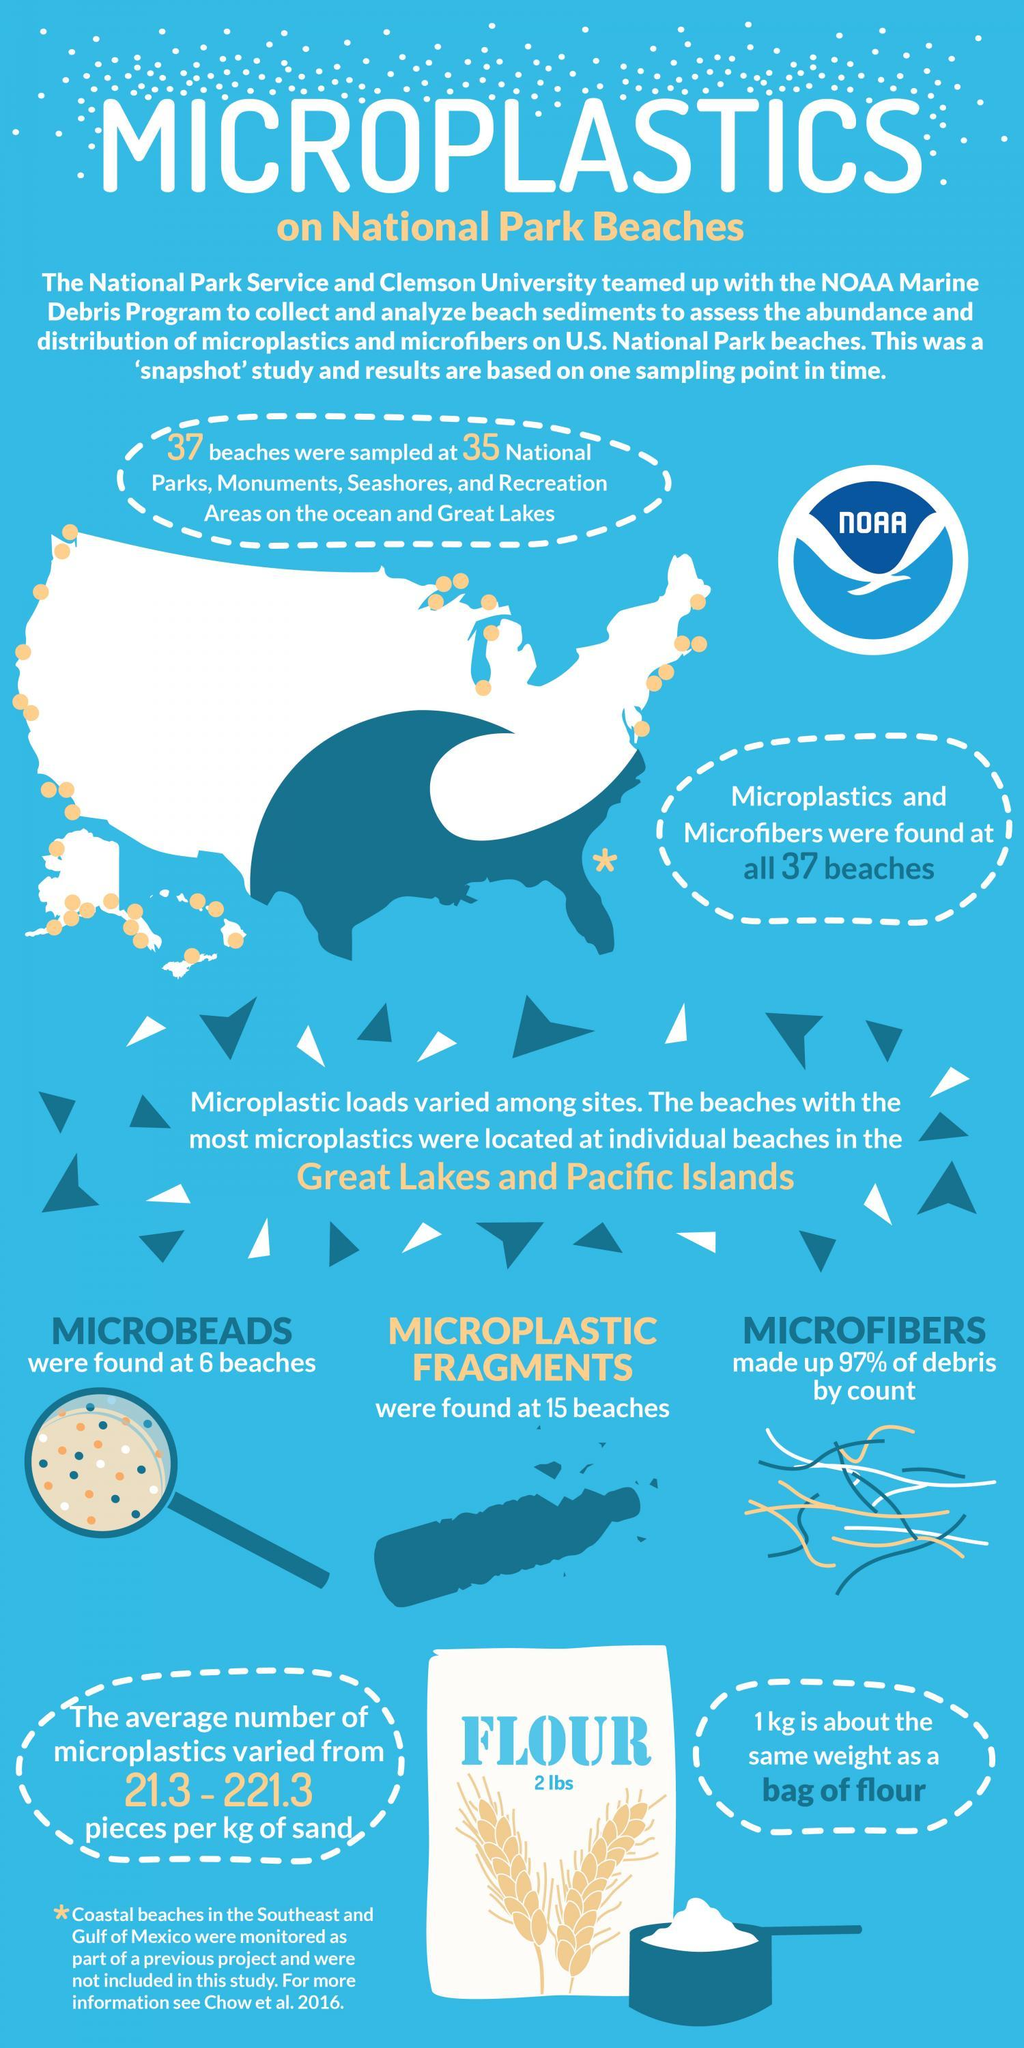What geometric shape is used in the map to indicate the beaches included in the study - square, triangle, circle?
Answer the question with a short phrase. circle What was found at 15 beaches? Microplastic fragments At how many locations were microbeads found? 6 97% of debris consisted of what item? Microfibers 